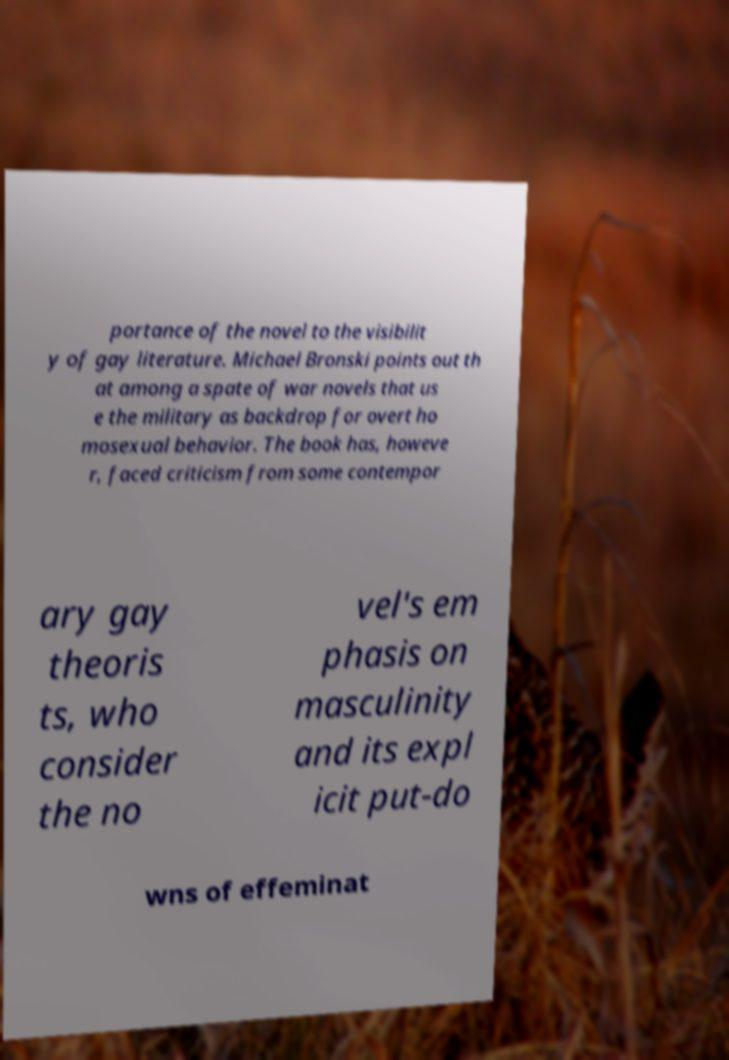Could you assist in decoding the text presented in this image and type it out clearly? portance of the novel to the visibilit y of gay literature. Michael Bronski points out th at among a spate of war novels that us e the military as backdrop for overt ho mosexual behavior. The book has, howeve r, faced criticism from some contempor ary gay theoris ts, who consider the no vel's em phasis on masculinity and its expl icit put-do wns of effeminat 